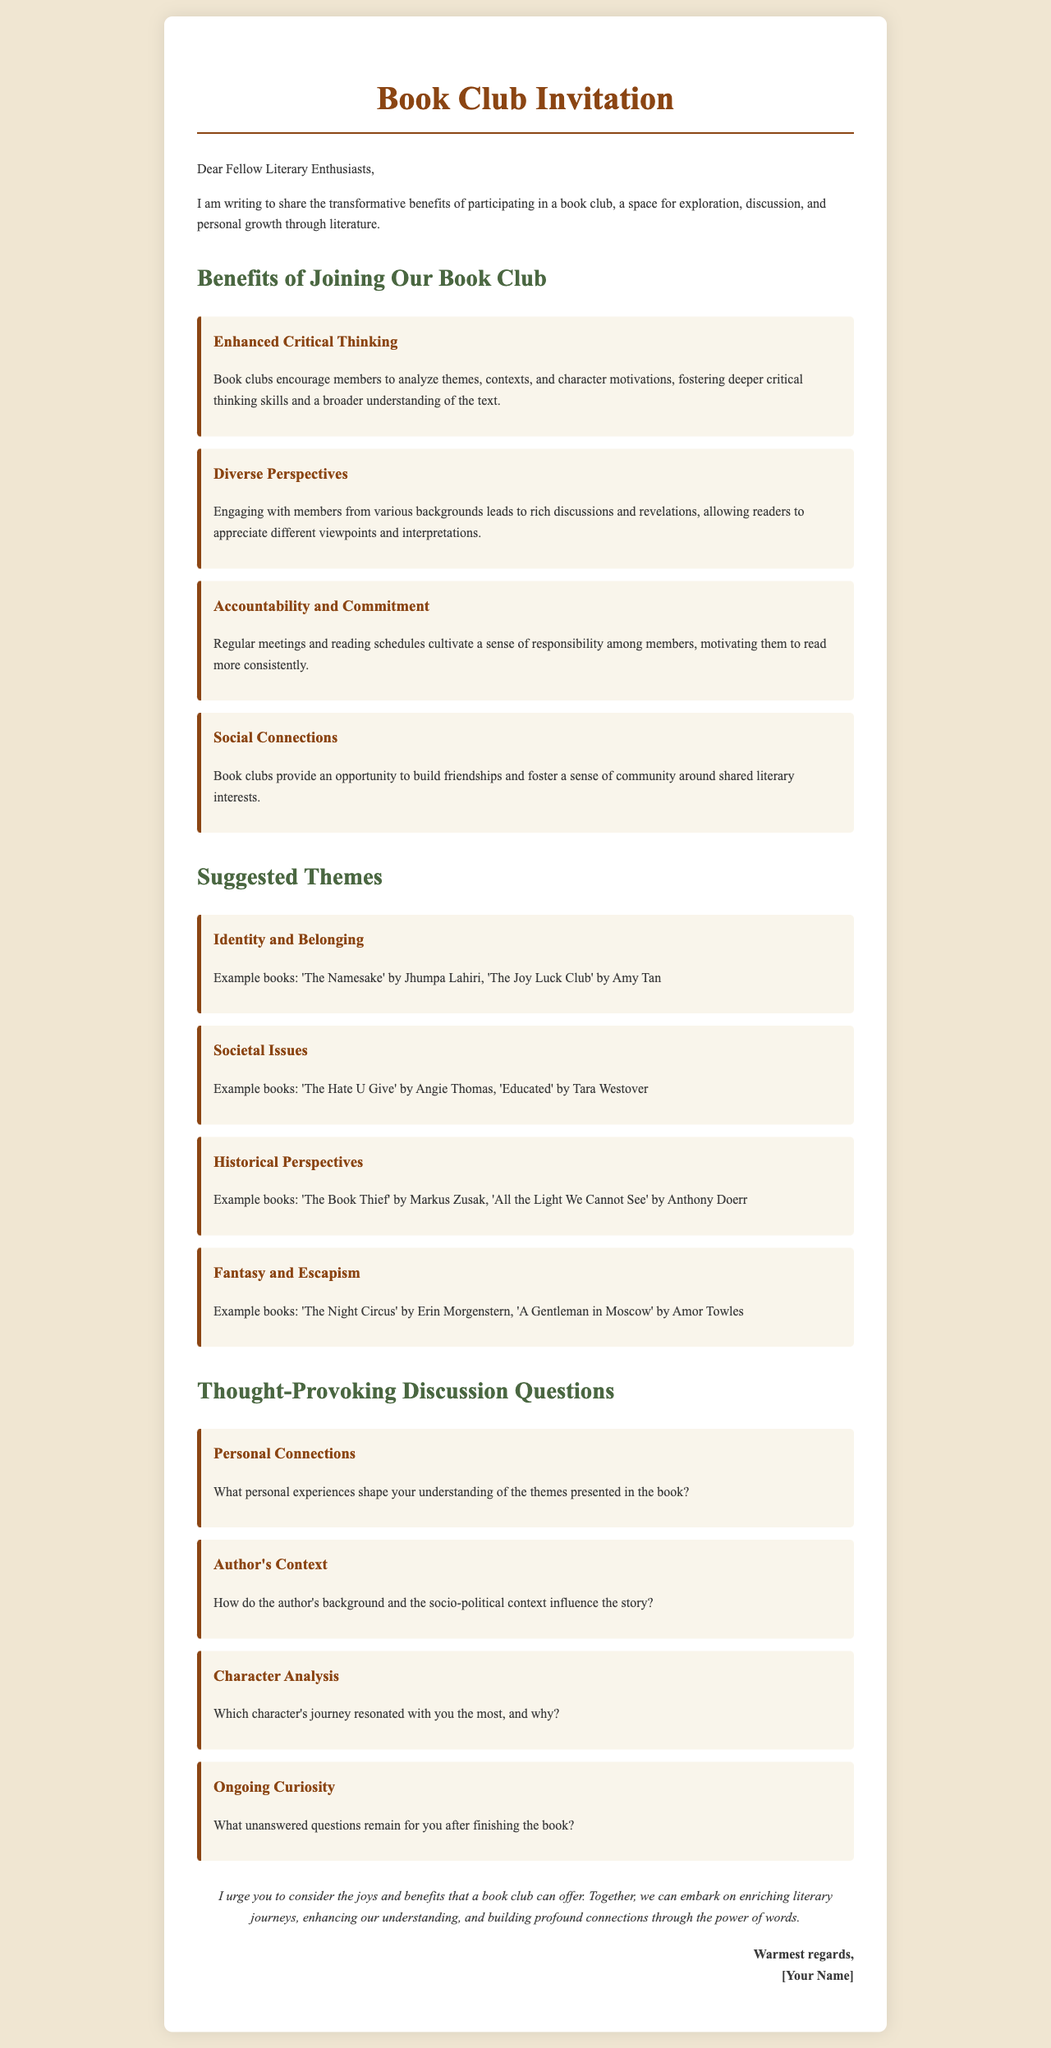What are two example books under the theme "Identity and Belonging"? The document lists 'The Namesake' by Jhumpa Lahiri and 'The Joy Luck Club' by Amy Tan as examples.
Answer: 'The Namesake', 'The Joy Luck Club' What benefit of joining a book club is directly related to discussions? The document states that engaging with members from various backgrounds leads to rich discussions, which suggests enhanced critical thinking.
Answer: Diverse Perspectives How many suggested themes are provided in the document? The document lists four suggested themes, each with example books.
Answer: Four What thought-provoking discussion question pertains to character analysis? The document provides the question about which character's journey resonated most, linking it to character analysis.
Answer: Which character's journey resonated with you the most, and why? What is one way a book club can help members with reading? According to the document, regular meetings and reading schedules cultivate a sense of responsibility among members.
Answer: Accountability and Commitment What is the primary focus of this document? The document is a letter inviting fellow literary enthusiasts to join a book club and outlining its benefits.
Answer: Book Club Invitation 